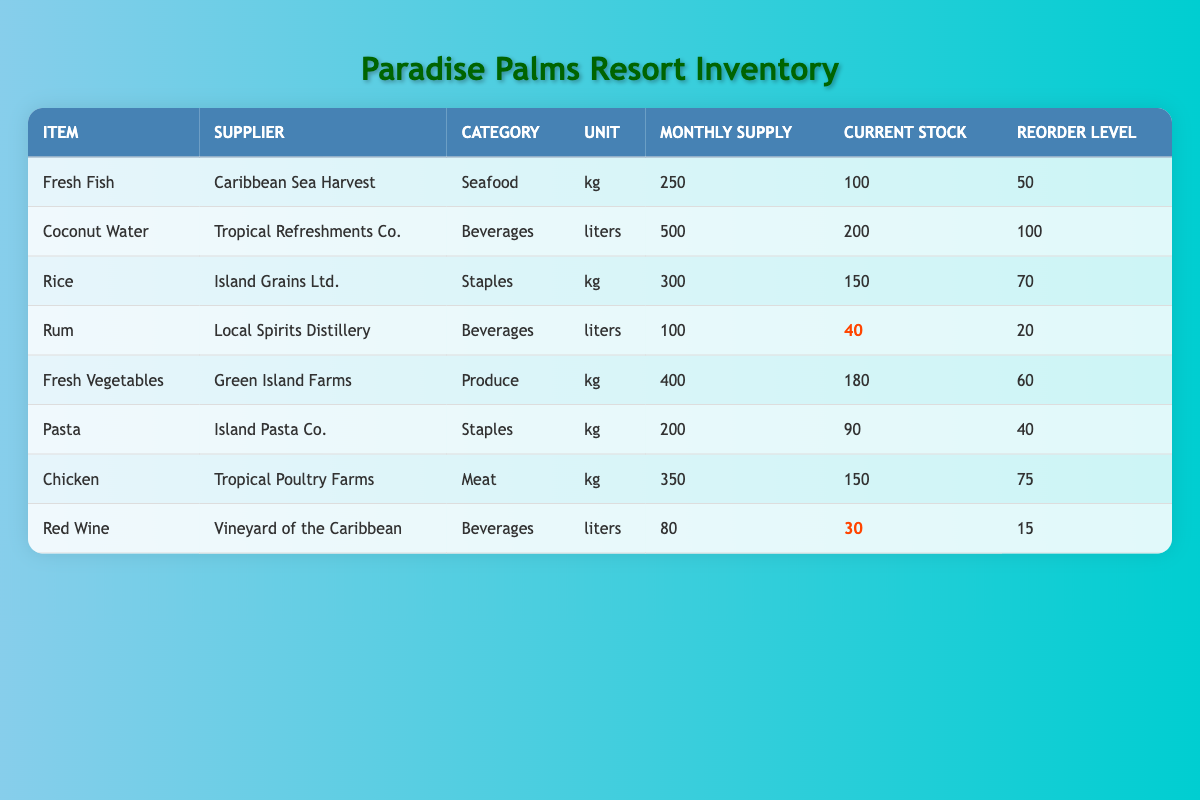What is the current stock level of Chicken? The table shows that the current stock level of Chicken is listed in the corresponding row under the "Current Stock" column. Referring to that row, the value is 150 kg.
Answer: 150 kg How many liters of Coconut Water are supplied monthly? The monthly supply of Coconut Water can be found in the row corresponding to Coconut Water, under the "Monthly Supply" column. The value there is 500 liters.
Answer: 500 liters Is the current stock of Red Wine below its reorder level? To determine if the current stock of Red Wine is below its reorder level, we check the "Current Stock" (30 liters) and the "Reorder Level" (15 liters) in the Red Wine row. Since 30 is greater than 15, the current stock is not below the reorder level.
Answer: No What is the total monthly supply of seafood (Fresh Fish)? From the table, the only seafood item listed is Fresh Fish. Its monthly supply is 250 kg. Since there are no other seafood items mentioned, the total monthly supply of seafood is the same as that for Fresh Fish: 250 kg.
Answer: 250 kg What is the average current stock among all beverage items? To find the average current stock of beverage items, we first identify the relevant items: Coconut Water (200 liters), Rum (40 liters), and Red Wine (30 liters). We sum these current stocks: 200 + 40 + 30 = 270 liters. Next, we divide by the number of beverage items, which is 3, giving us an average of 270/3 = 90 liters.
Answer: 90 liters How much more of Fresh Vegetables is needed to reach its reorder level? Looking at the Fresh Vegetables row, the current stock is 180 kg and the reorder level is 60 kg. To find how much more is needed to reach the reorder level, subtract the current stock from the reorder level: 60 - 180 = -120 kg. Since the current stock exceeds the reorder level, it is not needed, which means there is actually a surplus.
Answer: 0 kg How many kg of Rice can be supplied if we run out and reach reorder levels? From the Rice row, the reorder level is stated as 70 kg. Since running out means reaching exactly that reorder level, the monthly supply is not affected by this situation; therefore, we can still supply 300 kg of Rice as indicated.
Answer: 300 kg Is there sufficient stock of Rum for the month based on its monthly supply? The monthly supply of Rum is 100 liters while the current stock is 40 liters. Since 40 liters is less than the monthly supply, there is not sufficient stock of Rum to cover the entire month's supply.
Answer: No 